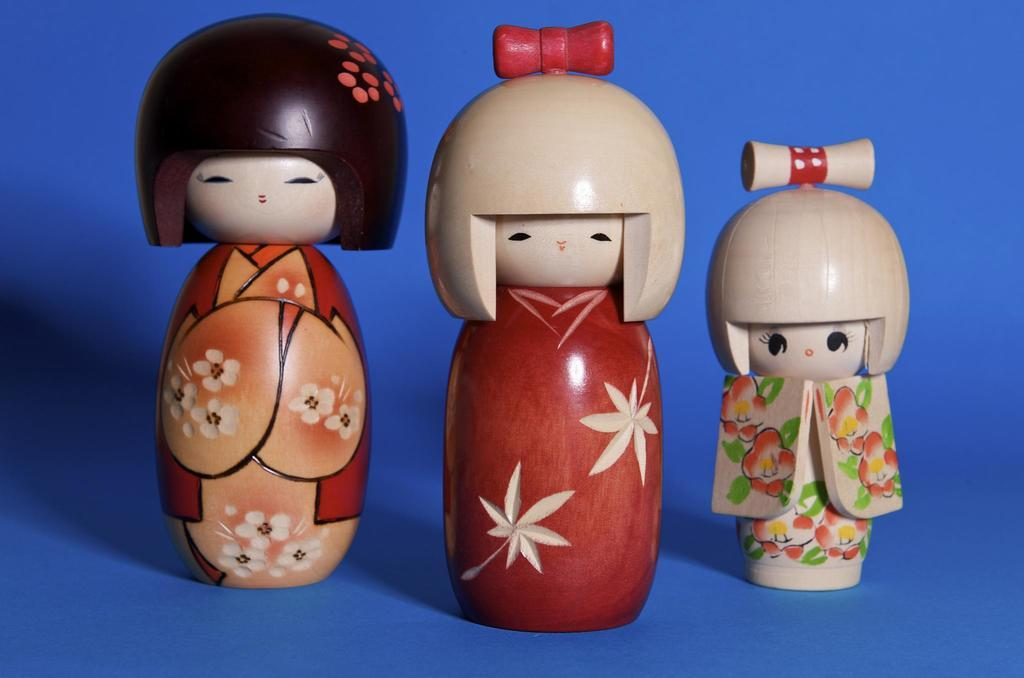How many toys are present in the image? There are three toys in the image. What can be seen in the background of the image? The background of the image is black. Where is the kettle located in the image? There is no kettle present in the image. What type of farming equipment can be seen in the image? There is no farming equipment, such as a plough, present in the image. 